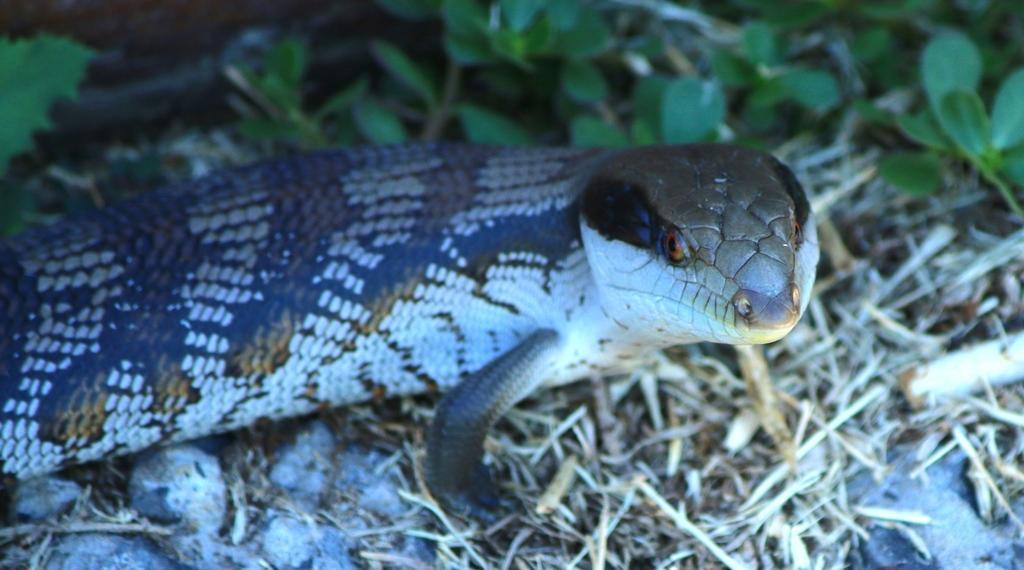Could you give a brief overview of what you see in this image? In this picture we can see a reptile, sticks, leaves on the ground and in the background it is dark. 